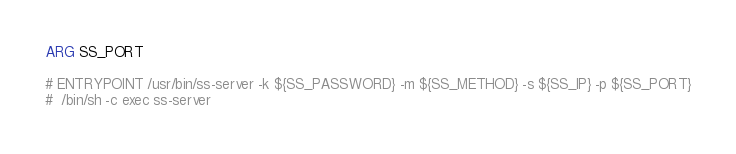Convert code to text. <code><loc_0><loc_0><loc_500><loc_500><_Dockerfile_>ARG SS_PORT

# ENTRYPOINT /usr/bin/ss-server -k ${SS_PASSWORD} -m ${SS_METHOD} -s ${SS_IP} -p ${SS_PORT}
#  /bin/sh -c exec ss-server</code> 